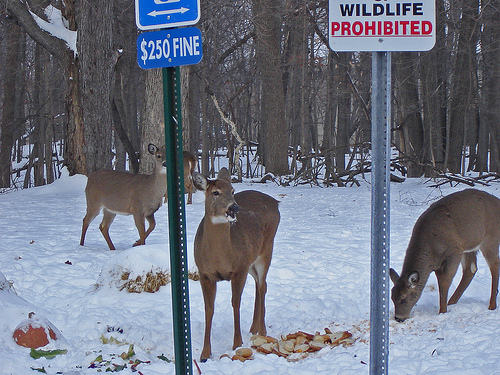<image>
Is there a dear on the floor? Yes. Looking at the image, I can see the dear is positioned on top of the floor, with the floor providing support. Is the deer behind the sign? Yes. From this viewpoint, the deer is positioned behind the sign, with the sign partially or fully occluding the deer. Is the tree behind the deer? Yes. From this viewpoint, the tree is positioned behind the deer, with the deer partially or fully occluding the tree. Is the sign board to the left of the deer? Yes. From this viewpoint, the sign board is positioned to the left side relative to the deer. Is there a deer in front of the sign? No. The deer is not in front of the sign. The spatial positioning shows a different relationship between these objects. 